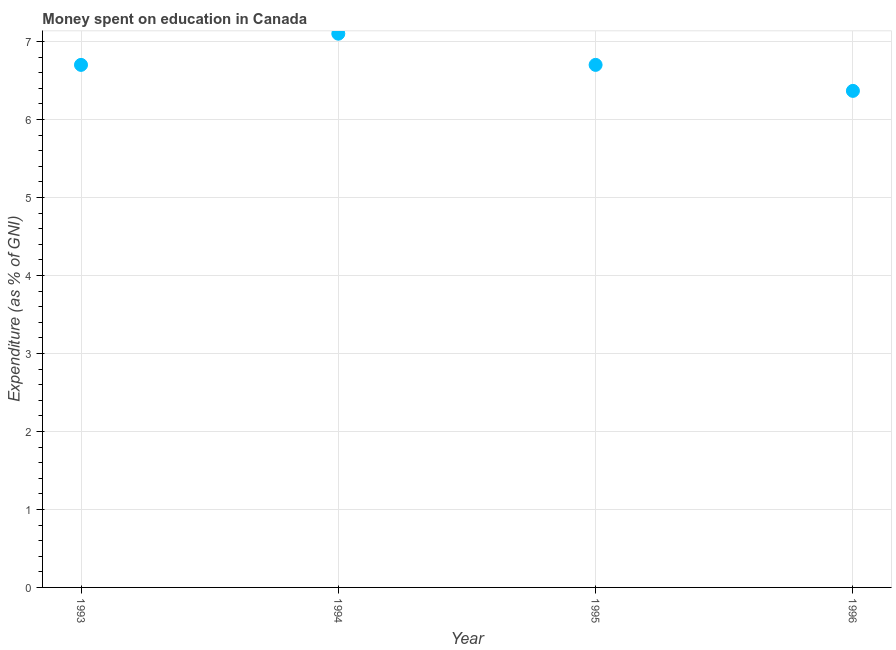Across all years, what is the maximum expenditure on education?
Your response must be concise. 7.1. Across all years, what is the minimum expenditure on education?
Ensure brevity in your answer.  6.37. In which year was the expenditure on education maximum?
Offer a very short reply. 1994. In which year was the expenditure on education minimum?
Give a very brief answer. 1996. What is the sum of the expenditure on education?
Ensure brevity in your answer.  26.87. What is the difference between the expenditure on education in 1993 and 1994?
Make the answer very short. -0.4. What is the average expenditure on education per year?
Your answer should be compact. 6.72. What is the ratio of the expenditure on education in 1993 to that in 1996?
Provide a succinct answer. 1.05. Is the difference between the expenditure on education in 1993 and 1994 greater than the difference between any two years?
Provide a short and direct response. No. What is the difference between the highest and the second highest expenditure on education?
Provide a short and direct response. 0.4. What is the difference between the highest and the lowest expenditure on education?
Provide a succinct answer. 0.73. Does the expenditure on education monotonically increase over the years?
Provide a short and direct response. No. Does the graph contain any zero values?
Offer a terse response. No. Does the graph contain grids?
Your answer should be compact. Yes. What is the title of the graph?
Offer a terse response. Money spent on education in Canada. What is the label or title of the X-axis?
Offer a very short reply. Year. What is the label or title of the Y-axis?
Offer a very short reply. Expenditure (as % of GNI). What is the Expenditure (as % of GNI) in 1995?
Keep it short and to the point. 6.7. What is the Expenditure (as % of GNI) in 1996?
Offer a very short reply. 6.37. What is the difference between the Expenditure (as % of GNI) in 1993 and 1994?
Offer a terse response. -0.4. What is the difference between the Expenditure (as % of GNI) in 1993 and 1995?
Provide a short and direct response. 0. What is the difference between the Expenditure (as % of GNI) in 1993 and 1996?
Keep it short and to the point. 0.33. What is the difference between the Expenditure (as % of GNI) in 1994 and 1995?
Your answer should be very brief. 0.4. What is the difference between the Expenditure (as % of GNI) in 1994 and 1996?
Provide a short and direct response. 0.73. What is the difference between the Expenditure (as % of GNI) in 1995 and 1996?
Give a very brief answer. 0.33. What is the ratio of the Expenditure (as % of GNI) in 1993 to that in 1994?
Ensure brevity in your answer.  0.94. What is the ratio of the Expenditure (as % of GNI) in 1993 to that in 1996?
Ensure brevity in your answer.  1.05. What is the ratio of the Expenditure (as % of GNI) in 1994 to that in 1995?
Your answer should be very brief. 1.06. What is the ratio of the Expenditure (as % of GNI) in 1994 to that in 1996?
Keep it short and to the point. 1.11. What is the ratio of the Expenditure (as % of GNI) in 1995 to that in 1996?
Provide a succinct answer. 1.05. 